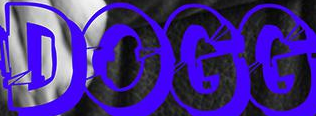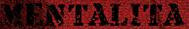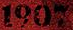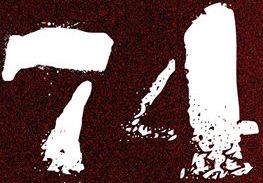Identify the words shown in these images in order, separated by a semicolon. DOGG; MENTALITA; 1907; 74 